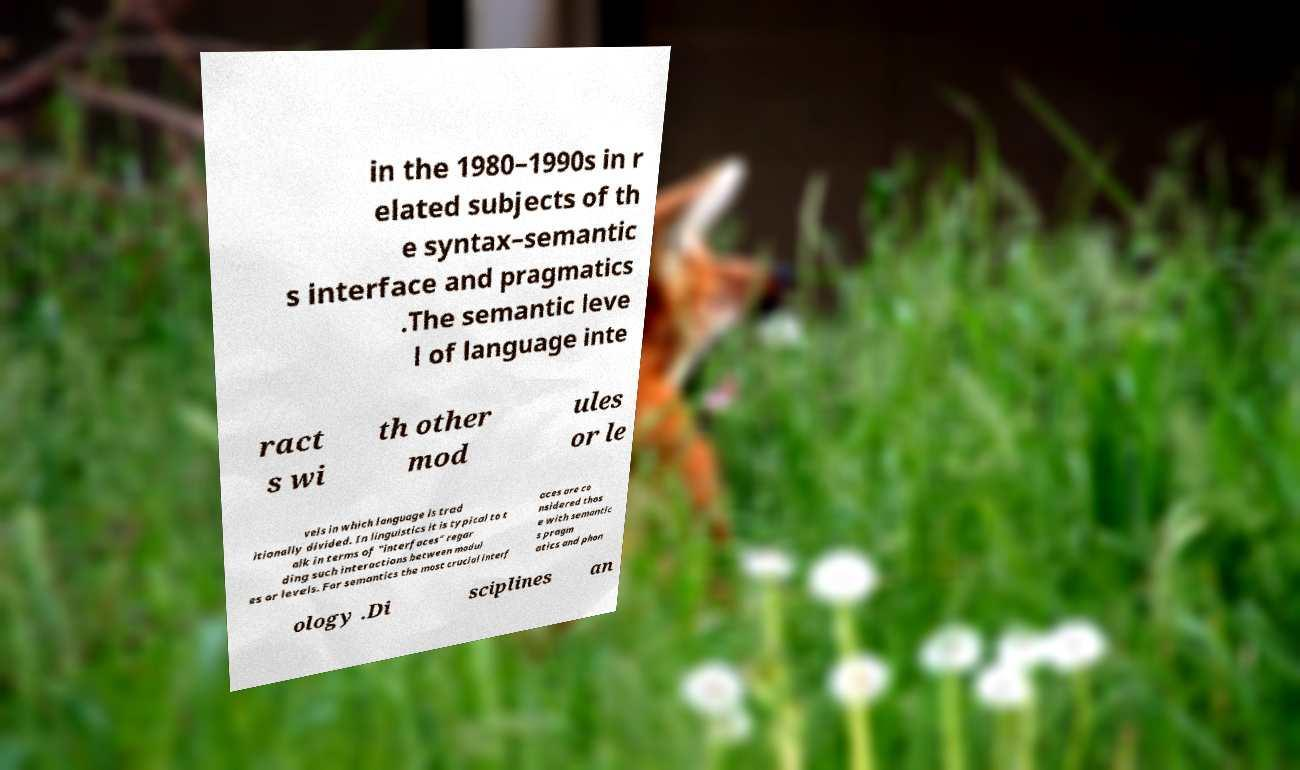Can you read and provide the text displayed in the image?This photo seems to have some interesting text. Can you extract and type it out for me? in the 1980–1990s in r elated subjects of th e syntax–semantic s interface and pragmatics .The semantic leve l of language inte ract s wi th other mod ules or le vels in which language is trad itionally divided. In linguistics it is typical to t alk in terms of "interfaces" regar ding such interactions between modul es or levels. For semantics the most crucial interf aces are co nsidered thos e with semantic s pragm atics and phon ology .Di sciplines an 